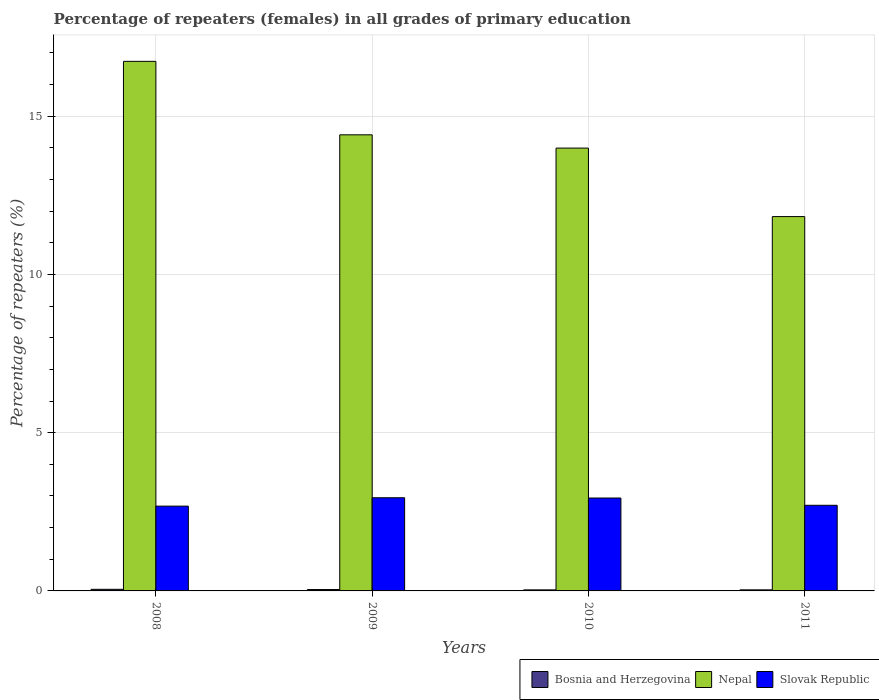Are the number of bars per tick equal to the number of legend labels?
Offer a terse response. Yes. Are the number of bars on each tick of the X-axis equal?
Give a very brief answer. Yes. What is the label of the 2nd group of bars from the left?
Your answer should be compact. 2009. What is the percentage of repeaters (females) in Nepal in 2011?
Your answer should be compact. 11.83. Across all years, what is the maximum percentage of repeaters (females) in Nepal?
Offer a terse response. 16.73. Across all years, what is the minimum percentage of repeaters (females) in Nepal?
Keep it short and to the point. 11.83. In which year was the percentage of repeaters (females) in Nepal maximum?
Offer a very short reply. 2008. In which year was the percentage of repeaters (females) in Bosnia and Herzegovina minimum?
Provide a succinct answer. 2010. What is the total percentage of repeaters (females) in Nepal in the graph?
Make the answer very short. 56.97. What is the difference between the percentage of repeaters (females) in Slovak Republic in 2010 and that in 2011?
Offer a terse response. 0.23. What is the difference between the percentage of repeaters (females) in Nepal in 2010 and the percentage of repeaters (females) in Slovak Republic in 2009?
Ensure brevity in your answer.  11.05. What is the average percentage of repeaters (females) in Bosnia and Herzegovina per year?
Ensure brevity in your answer.  0.04. In the year 2009, what is the difference between the percentage of repeaters (females) in Slovak Republic and percentage of repeaters (females) in Bosnia and Herzegovina?
Give a very brief answer. 2.9. In how many years, is the percentage of repeaters (females) in Nepal greater than 14 %?
Provide a short and direct response. 2. What is the ratio of the percentage of repeaters (females) in Nepal in 2008 to that in 2011?
Offer a very short reply. 1.41. What is the difference between the highest and the second highest percentage of repeaters (females) in Slovak Republic?
Your answer should be very brief. 0.01. What is the difference between the highest and the lowest percentage of repeaters (females) in Slovak Republic?
Provide a succinct answer. 0.26. In how many years, is the percentage of repeaters (females) in Slovak Republic greater than the average percentage of repeaters (females) in Slovak Republic taken over all years?
Offer a terse response. 2. What does the 2nd bar from the left in 2008 represents?
Provide a succinct answer. Nepal. What does the 3rd bar from the right in 2010 represents?
Offer a very short reply. Bosnia and Herzegovina. How many years are there in the graph?
Keep it short and to the point. 4. What is the difference between two consecutive major ticks on the Y-axis?
Make the answer very short. 5. Are the values on the major ticks of Y-axis written in scientific E-notation?
Offer a very short reply. No. Where does the legend appear in the graph?
Offer a very short reply. Bottom right. What is the title of the graph?
Give a very brief answer. Percentage of repeaters (females) in all grades of primary education. What is the label or title of the X-axis?
Keep it short and to the point. Years. What is the label or title of the Y-axis?
Offer a very short reply. Percentage of repeaters (%). What is the Percentage of repeaters (%) in Bosnia and Herzegovina in 2008?
Ensure brevity in your answer.  0.05. What is the Percentage of repeaters (%) of Nepal in 2008?
Your answer should be very brief. 16.73. What is the Percentage of repeaters (%) of Slovak Republic in 2008?
Offer a very short reply. 2.68. What is the Percentage of repeaters (%) in Bosnia and Herzegovina in 2009?
Ensure brevity in your answer.  0.04. What is the Percentage of repeaters (%) in Nepal in 2009?
Provide a short and direct response. 14.41. What is the Percentage of repeaters (%) of Slovak Republic in 2009?
Ensure brevity in your answer.  2.94. What is the Percentage of repeaters (%) in Bosnia and Herzegovina in 2010?
Provide a short and direct response. 0.03. What is the Percentage of repeaters (%) of Nepal in 2010?
Make the answer very short. 13.99. What is the Percentage of repeaters (%) in Slovak Republic in 2010?
Provide a succinct answer. 2.94. What is the Percentage of repeaters (%) in Bosnia and Herzegovina in 2011?
Ensure brevity in your answer.  0.03. What is the Percentage of repeaters (%) of Nepal in 2011?
Your answer should be very brief. 11.83. What is the Percentage of repeaters (%) in Slovak Republic in 2011?
Offer a very short reply. 2.71. Across all years, what is the maximum Percentage of repeaters (%) in Bosnia and Herzegovina?
Provide a succinct answer. 0.05. Across all years, what is the maximum Percentage of repeaters (%) in Nepal?
Make the answer very short. 16.73. Across all years, what is the maximum Percentage of repeaters (%) of Slovak Republic?
Provide a succinct answer. 2.94. Across all years, what is the minimum Percentage of repeaters (%) of Bosnia and Herzegovina?
Offer a very short reply. 0.03. Across all years, what is the minimum Percentage of repeaters (%) in Nepal?
Keep it short and to the point. 11.83. Across all years, what is the minimum Percentage of repeaters (%) of Slovak Republic?
Offer a terse response. 2.68. What is the total Percentage of repeaters (%) of Bosnia and Herzegovina in the graph?
Provide a short and direct response. 0.16. What is the total Percentage of repeaters (%) in Nepal in the graph?
Your response must be concise. 56.97. What is the total Percentage of repeaters (%) of Slovak Republic in the graph?
Keep it short and to the point. 11.26. What is the difference between the Percentage of repeaters (%) in Bosnia and Herzegovina in 2008 and that in 2009?
Keep it short and to the point. 0.01. What is the difference between the Percentage of repeaters (%) of Nepal in 2008 and that in 2009?
Offer a terse response. 2.32. What is the difference between the Percentage of repeaters (%) of Slovak Republic in 2008 and that in 2009?
Make the answer very short. -0.26. What is the difference between the Percentage of repeaters (%) in Bosnia and Herzegovina in 2008 and that in 2010?
Ensure brevity in your answer.  0.02. What is the difference between the Percentage of repeaters (%) of Nepal in 2008 and that in 2010?
Offer a terse response. 2.74. What is the difference between the Percentage of repeaters (%) of Slovak Republic in 2008 and that in 2010?
Your answer should be very brief. -0.26. What is the difference between the Percentage of repeaters (%) in Bosnia and Herzegovina in 2008 and that in 2011?
Ensure brevity in your answer.  0.02. What is the difference between the Percentage of repeaters (%) of Nepal in 2008 and that in 2011?
Your answer should be compact. 4.91. What is the difference between the Percentage of repeaters (%) in Slovak Republic in 2008 and that in 2011?
Offer a terse response. -0.03. What is the difference between the Percentage of repeaters (%) of Bosnia and Herzegovina in 2009 and that in 2010?
Offer a very short reply. 0.01. What is the difference between the Percentage of repeaters (%) of Nepal in 2009 and that in 2010?
Your answer should be very brief. 0.42. What is the difference between the Percentage of repeaters (%) in Slovak Republic in 2009 and that in 2010?
Keep it short and to the point. 0.01. What is the difference between the Percentage of repeaters (%) of Bosnia and Herzegovina in 2009 and that in 2011?
Make the answer very short. 0.01. What is the difference between the Percentage of repeaters (%) in Nepal in 2009 and that in 2011?
Ensure brevity in your answer.  2.58. What is the difference between the Percentage of repeaters (%) of Slovak Republic in 2009 and that in 2011?
Ensure brevity in your answer.  0.24. What is the difference between the Percentage of repeaters (%) of Bosnia and Herzegovina in 2010 and that in 2011?
Your response must be concise. -0. What is the difference between the Percentage of repeaters (%) of Nepal in 2010 and that in 2011?
Provide a short and direct response. 2.16. What is the difference between the Percentage of repeaters (%) in Slovak Republic in 2010 and that in 2011?
Ensure brevity in your answer.  0.23. What is the difference between the Percentage of repeaters (%) in Bosnia and Herzegovina in 2008 and the Percentage of repeaters (%) in Nepal in 2009?
Make the answer very short. -14.36. What is the difference between the Percentage of repeaters (%) of Bosnia and Herzegovina in 2008 and the Percentage of repeaters (%) of Slovak Republic in 2009?
Your response must be concise. -2.89. What is the difference between the Percentage of repeaters (%) in Nepal in 2008 and the Percentage of repeaters (%) in Slovak Republic in 2009?
Offer a very short reply. 13.79. What is the difference between the Percentage of repeaters (%) of Bosnia and Herzegovina in 2008 and the Percentage of repeaters (%) of Nepal in 2010?
Give a very brief answer. -13.94. What is the difference between the Percentage of repeaters (%) in Bosnia and Herzegovina in 2008 and the Percentage of repeaters (%) in Slovak Republic in 2010?
Keep it short and to the point. -2.88. What is the difference between the Percentage of repeaters (%) of Nepal in 2008 and the Percentage of repeaters (%) of Slovak Republic in 2010?
Offer a terse response. 13.8. What is the difference between the Percentage of repeaters (%) of Bosnia and Herzegovina in 2008 and the Percentage of repeaters (%) of Nepal in 2011?
Give a very brief answer. -11.78. What is the difference between the Percentage of repeaters (%) of Bosnia and Herzegovina in 2008 and the Percentage of repeaters (%) of Slovak Republic in 2011?
Keep it short and to the point. -2.66. What is the difference between the Percentage of repeaters (%) of Nepal in 2008 and the Percentage of repeaters (%) of Slovak Republic in 2011?
Your answer should be very brief. 14.03. What is the difference between the Percentage of repeaters (%) in Bosnia and Herzegovina in 2009 and the Percentage of repeaters (%) in Nepal in 2010?
Make the answer very short. -13.95. What is the difference between the Percentage of repeaters (%) in Bosnia and Herzegovina in 2009 and the Percentage of repeaters (%) in Slovak Republic in 2010?
Ensure brevity in your answer.  -2.89. What is the difference between the Percentage of repeaters (%) in Nepal in 2009 and the Percentage of repeaters (%) in Slovak Republic in 2010?
Offer a terse response. 11.48. What is the difference between the Percentage of repeaters (%) in Bosnia and Herzegovina in 2009 and the Percentage of repeaters (%) in Nepal in 2011?
Provide a short and direct response. -11.79. What is the difference between the Percentage of repeaters (%) in Bosnia and Herzegovina in 2009 and the Percentage of repeaters (%) in Slovak Republic in 2011?
Provide a succinct answer. -2.66. What is the difference between the Percentage of repeaters (%) in Nepal in 2009 and the Percentage of repeaters (%) in Slovak Republic in 2011?
Keep it short and to the point. 11.71. What is the difference between the Percentage of repeaters (%) in Bosnia and Herzegovina in 2010 and the Percentage of repeaters (%) in Nepal in 2011?
Your response must be concise. -11.8. What is the difference between the Percentage of repeaters (%) in Bosnia and Herzegovina in 2010 and the Percentage of repeaters (%) in Slovak Republic in 2011?
Provide a short and direct response. -2.67. What is the difference between the Percentage of repeaters (%) of Nepal in 2010 and the Percentage of repeaters (%) of Slovak Republic in 2011?
Offer a terse response. 11.29. What is the average Percentage of repeaters (%) of Bosnia and Herzegovina per year?
Keep it short and to the point. 0.04. What is the average Percentage of repeaters (%) of Nepal per year?
Keep it short and to the point. 14.24. What is the average Percentage of repeaters (%) in Slovak Republic per year?
Keep it short and to the point. 2.82. In the year 2008, what is the difference between the Percentage of repeaters (%) in Bosnia and Herzegovina and Percentage of repeaters (%) in Nepal?
Provide a succinct answer. -16.68. In the year 2008, what is the difference between the Percentage of repeaters (%) in Bosnia and Herzegovina and Percentage of repeaters (%) in Slovak Republic?
Your answer should be very brief. -2.63. In the year 2008, what is the difference between the Percentage of repeaters (%) of Nepal and Percentage of repeaters (%) of Slovak Republic?
Offer a very short reply. 14.05. In the year 2009, what is the difference between the Percentage of repeaters (%) of Bosnia and Herzegovina and Percentage of repeaters (%) of Nepal?
Make the answer very short. -14.37. In the year 2009, what is the difference between the Percentage of repeaters (%) of Bosnia and Herzegovina and Percentage of repeaters (%) of Slovak Republic?
Ensure brevity in your answer.  -2.9. In the year 2009, what is the difference between the Percentage of repeaters (%) of Nepal and Percentage of repeaters (%) of Slovak Republic?
Give a very brief answer. 11.47. In the year 2010, what is the difference between the Percentage of repeaters (%) of Bosnia and Herzegovina and Percentage of repeaters (%) of Nepal?
Offer a terse response. -13.96. In the year 2010, what is the difference between the Percentage of repeaters (%) in Bosnia and Herzegovina and Percentage of repeaters (%) in Slovak Republic?
Offer a very short reply. -2.9. In the year 2010, what is the difference between the Percentage of repeaters (%) of Nepal and Percentage of repeaters (%) of Slovak Republic?
Your answer should be compact. 11.06. In the year 2011, what is the difference between the Percentage of repeaters (%) of Bosnia and Herzegovina and Percentage of repeaters (%) of Nepal?
Ensure brevity in your answer.  -11.79. In the year 2011, what is the difference between the Percentage of repeaters (%) in Bosnia and Herzegovina and Percentage of repeaters (%) in Slovak Republic?
Keep it short and to the point. -2.67. In the year 2011, what is the difference between the Percentage of repeaters (%) of Nepal and Percentage of repeaters (%) of Slovak Republic?
Provide a succinct answer. 9.12. What is the ratio of the Percentage of repeaters (%) of Bosnia and Herzegovina in 2008 to that in 2009?
Keep it short and to the point. 1.17. What is the ratio of the Percentage of repeaters (%) of Nepal in 2008 to that in 2009?
Keep it short and to the point. 1.16. What is the ratio of the Percentage of repeaters (%) in Slovak Republic in 2008 to that in 2009?
Ensure brevity in your answer.  0.91. What is the ratio of the Percentage of repeaters (%) in Bosnia and Herzegovina in 2008 to that in 2010?
Provide a succinct answer. 1.55. What is the ratio of the Percentage of repeaters (%) of Nepal in 2008 to that in 2010?
Provide a short and direct response. 1.2. What is the ratio of the Percentage of repeaters (%) of Slovak Republic in 2008 to that in 2010?
Provide a short and direct response. 0.91. What is the ratio of the Percentage of repeaters (%) in Bosnia and Herzegovina in 2008 to that in 2011?
Give a very brief answer. 1.51. What is the ratio of the Percentage of repeaters (%) in Nepal in 2008 to that in 2011?
Provide a short and direct response. 1.41. What is the ratio of the Percentage of repeaters (%) of Bosnia and Herzegovina in 2009 to that in 2010?
Your answer should be very brief. 1.33. What is the ratio of the Percentage of repeaters (%) of Nepal in 2009 to that in 2010?
Your answer should be very brief. 1.03. What is the ratio of the Percentage of repeaters (%) of Slovak Republic in 2009 to that in 2010?
Offer a very short reply. 1. What is the ratio of the Percentage of repeaters (%) of Bosnia and Herzegovina in 2009 to that in 2011?
Offer a terse response. 1.29. What is the ratio of the Percentage of repeaters (%) of Nepal in 2009 to that in 2011?
Offer a very short reply. 1.22. What is the ratio of the Percentage of repeaters (%) in Slovak Republic in 2009 to that in 2011?
Make the answer very short. 1.09. What is the ratio of the Percentage of repeaters (%) in Bosnia and Herzegovina in 2010 to that in 2011?
Give a very brief answer. 0.97. What is the ratio of the Percentage of repeaters (%) in Nepal in 2010 to that in 2011?
Offer a very short reply. 1.18. What is the ratio of the Percentage of repeaters (%) in Slovak Republic in 2010 to that in 2011?
Offer a very short reply. 1.08. What is the difference between the highest and the second highest Percentage of repeaters (%) in Bosnia and Herzegovina?
Offer a very short reply. 0.01. What is the difference between the highest and the second highest Percentage of repeaters (%) of Nepal?
Ensure brevity in your answer.  2.32. What is the difference between the highest and the second highest Percentage of repeaters (%) in Slovak Republic?
Offer a very short reply. 0.01. What is the difference between the highest and the lowest Percentage of repeaters (%) in Bosnia and Herzegovina?
Your answer should be compact. 0.02. What is the difference between the highest and the lowest Percentage of repeaters (%) in Nepal?
Keep it short and to the point. 4.91. What is the difference between the highest and the lowest Percentage of repeaters (%) of Slovak Republic?
Give a very brief answer. 0.26. 